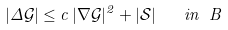Convert formula to latex. <formula><loc_0><loc_0><loc_500><loc_500>| \Delta \mathcal { G } | \leq c \, | \nabla \mathcal { G } | ^ { 2 } + | \mathcal { S } | \quad i n \ B</formula> 